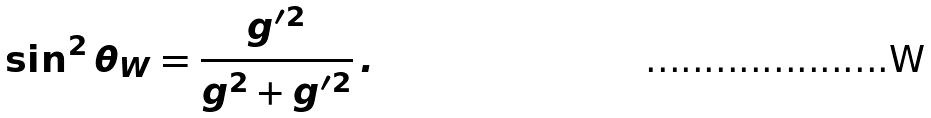Convert formula to latex. <formula><loc_0><loc_0><loc_500><loc_500>\sin ^ { 2 } \theta _ { W } = \frac { g ^ { \prime 2 } } { g ^ { 2 } + g ^ { \prime 2 } } \, .</formula> 